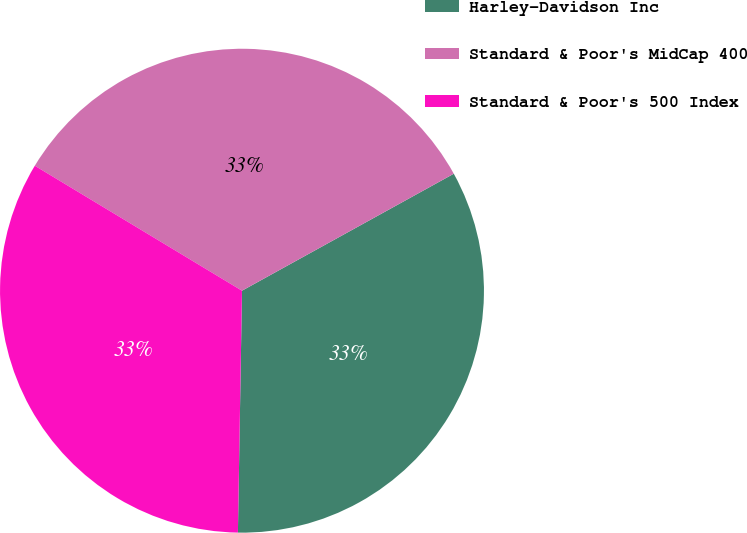Convert chart. <chart><loc_0><loc_0><loc_500><loc_500><pie_chart><fcel>Harley-Davidson Inc<fcel>Standard & Poor's MidCap 400<fcel>Standard & Poor's 500 Index<nl><fcel>33.3%<fcel>33.33%<fcel>33.37%<nl></chart> 